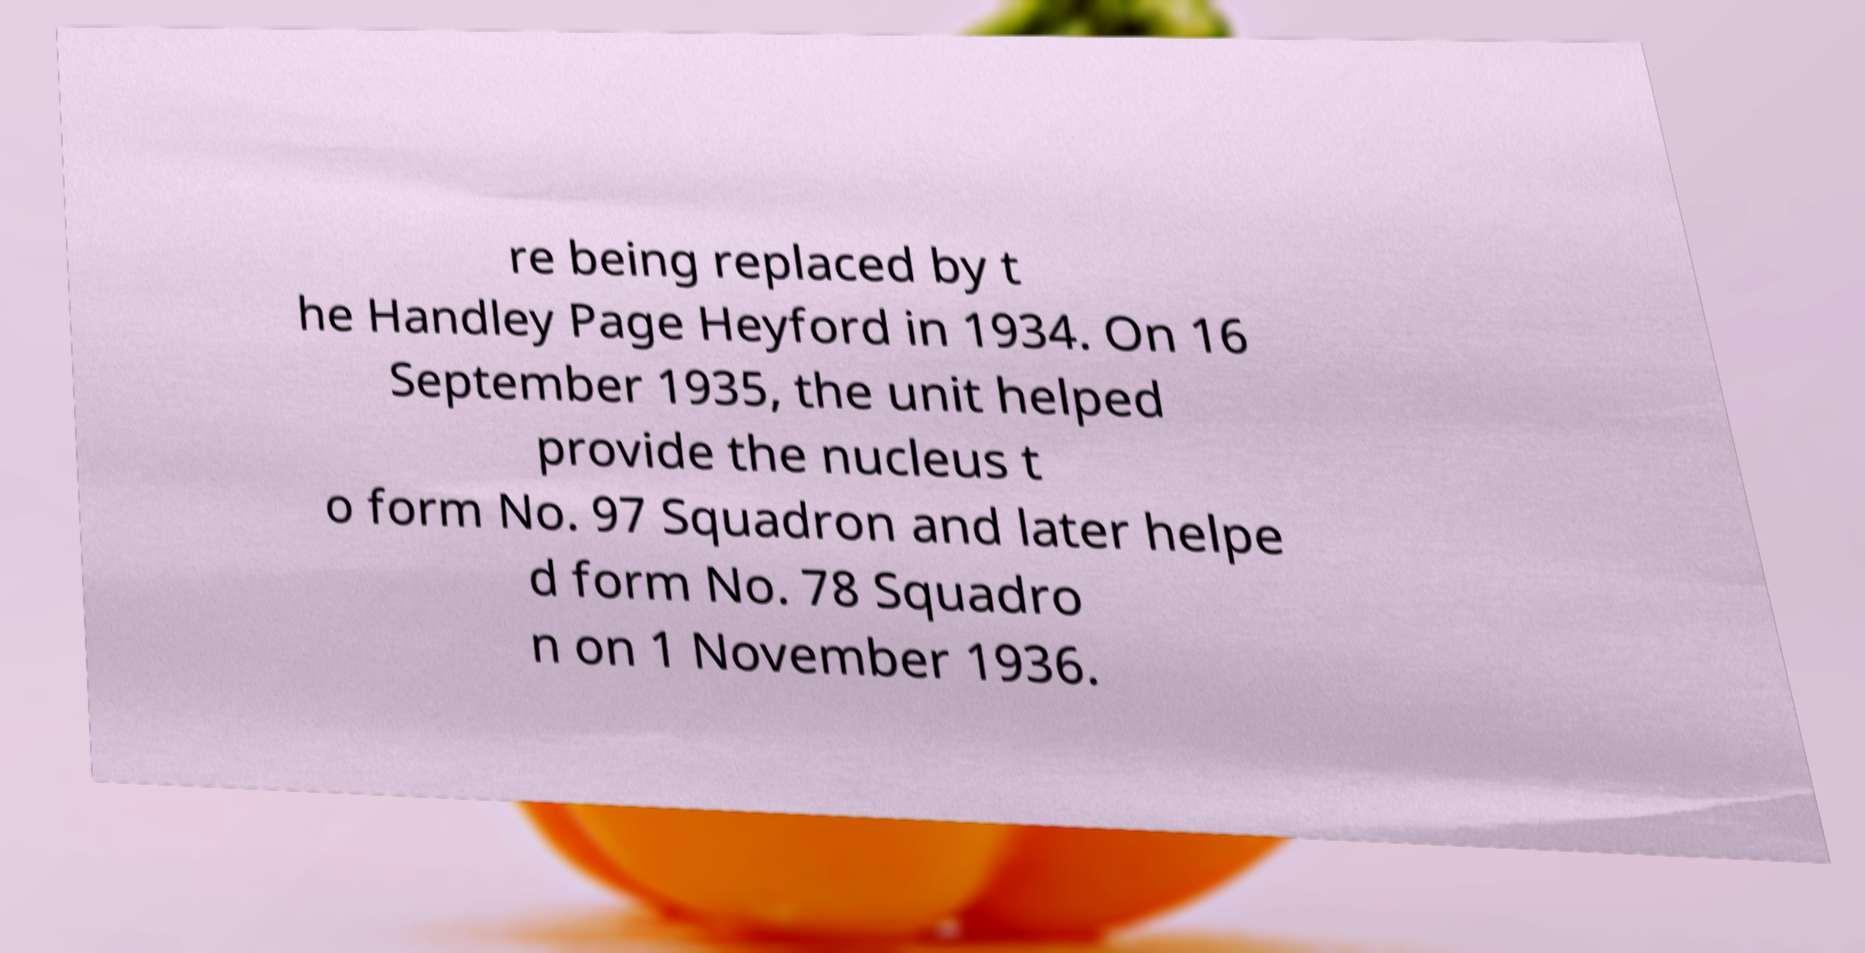Can you read and provide the text displayed in the image?This photo seems to have some interesting text. Can you extract and type it out for me? re being replaced by t he Handley Page Heyford in 1934. On 16 September 1935, the unit helped provide the nucleus t o form No. 97 Squadron and later helpe d form No. 78 Squadro n on 1 November 1936. 